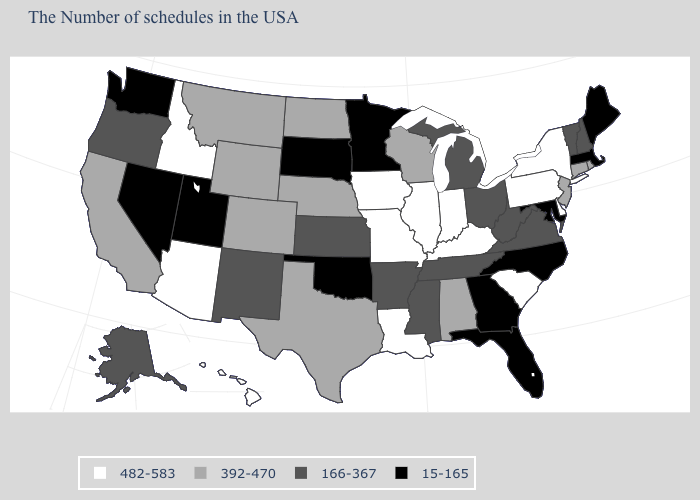What is the value of New York?
Short answer required. 482-583. Name the states that have a value in the range 166-367?
Give a very brief answer. New Hampshire, Vermont, Virginia, West Virginia, Ohio, Michigan, Tennessee, Mississippi, Arkansas, Kansas, New Mexico, Oregon, Alaska. What is the value of Virginia?
Quick response, please. 166-367. Which states have the highest value in the USA?
Be succinct. New York, Delaware, Pennsylvania, South Carolina, Kentucky, Indiana, Illinois, Louisiana, Missouri, Iowa, Arizona, Idaho, Hawaii. Which states hav the highest value in the West?
Answer briefly. Arizona, Idaho, Hawaii. Name the states that have a value in the range 482-583?
Write a very short answer. New York, Delaware, Pennsylvania, South Carolina, Kentucky, Indiana, Illinois, Louisiana, Missouri, Iowa, Arizona, Idaho, Hawaii. Does Montana have the highest value in the West?
Keep it brief. No. What is the highest value in the South ?
Be succinct. 482-583. What is the value of Arkansas?
Short answer required. 166-367. Name the states that have a value in the range 166-367?
Give a very brief answer. New Hampshire, Vermont, Virginia, West Virginia, Ohio, Michigan, Tennessee, Mississippi, Arkansas, Kansas, New Mexico, Oregon, Alaska. What is the value of Rhode Island?
Keep it brief. 392-470. Among the states that border Kentucky , does West Virginia have the lowest value?
Answer briefly. Yes. Does Massachusetts have the same value as Illinois?
Write a very short answer. No. Which states have the lowest value in the South?
Be succinct. Maryland, North Carolina, Florida, Georgia, Oklahoma. Which states have the highest value in the USA?
Keep it brief. New York, Delaware, Pennsylvania, South Carolina, Kentucky, Indiana, Illinois, Louisiana, Missouri, Iowa, Arizona, Idaho, Hawaii. 